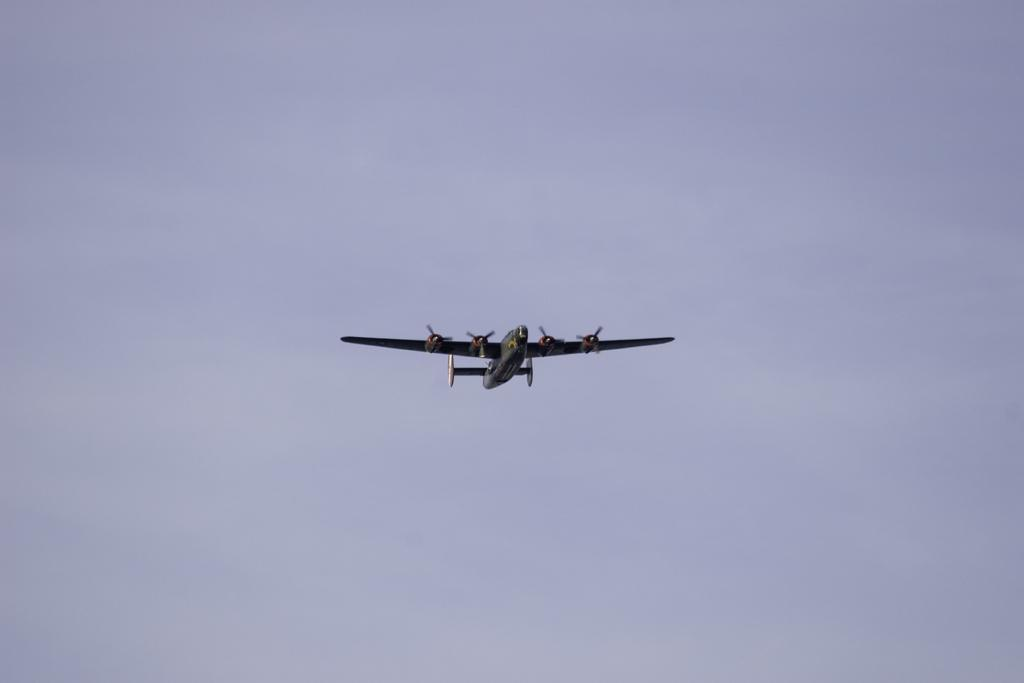What is the main subject of the image? The main subject of the image is a plane. What is the plane doing in the image? The plane is flying in the air. What can be seen in the background of the image? The sky is visible in the background of the image. What type of jam is the farmer holding in the image? There is no farmer or jam present in the image; it features a plane flying in the air. What arithmetic problem is being solved by the plane in the image? Planes do not solve arithmetic problems; they are vehicles designed for transportation. 